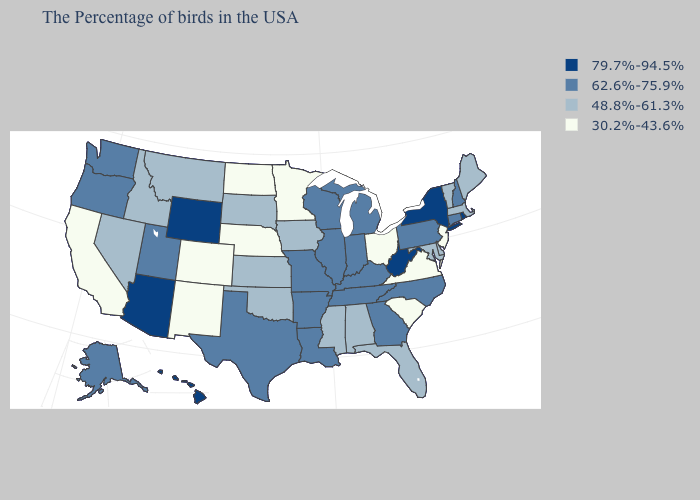Does New Jersey have the lowest value in the Northeast?
Write a very short answer. Yes. What is the value of Alaska?
Keep it brief. 62.6%-75.9%. What is the value of Michigan?
Keep it brief. 62.6%-75.9%. Among the states that border Indiana , which have the highest value?
Quick response, please. Michigan, Kentucky, Illinois. Name the states that have a value in the range 30.2%-43.6%?
Be succinct. New Jersey, Virginia, South Carolina, Ohio, Minnesota, Nebraska, North Dakota, Colorado, New Mexico, California. Name the states that have a value in the range 30.2%-43.6%?
Quick response, please. New Jersey, Virginia, South Carolina, Ohio, Minnesota, Nebraska, North Dakota, Colorado, New Mexico, California. Name the states that have a value in the range 79.7%-94.5%?
Quick response, please. Rhode Island, New York, West Virginia, Wyoming, Arizona, Hawaii. What is the value of Washington?
Short answer required. 62.6%-75.9%. What is the lowest value in states that border Utah?
Be succinct. 30.2%-43.6%. How many symbols are there in the legend?
Write a very short answer. 4. Name the states that have a value in the range 62.6%-75.9%?
Concise answer only. New Hampshire, Connecticut, Pennsylvania, North Carolina, Georgia, Michigan, Kentucky, Indiana, Tennessee, Wisconsin, Illinois, Louisiana, Missouri, Arkansas, Texas, Utah, Washington, Oregon, Alaska. What is the lowest value in the MidWest?
Give a very brief answer. 30.2%-43.6%. Does Oregon have a lower value than New York?
Keep it brief. Yes. Which states have the lowest value in the MidWest?
Short answer required. Ohio, Minnesota, Nebraska, North Dakota. Among the states that border California , does Arizona have the highest value?
Give a very brief answer. Yes. 